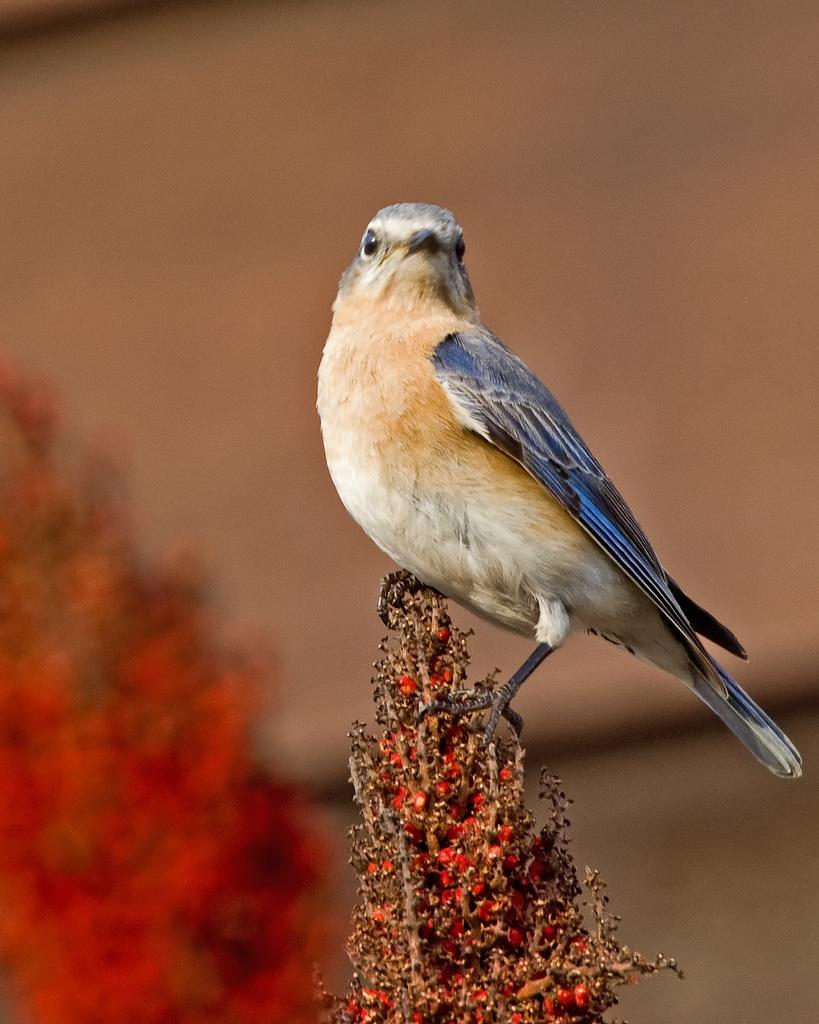What type of animal can be seen in the image? There is a bird in the image. Where is the bird located? The bird is on a plant. What type of cup is the bird holding in the image? There is no cup present in the image; the bird is on a plant. 